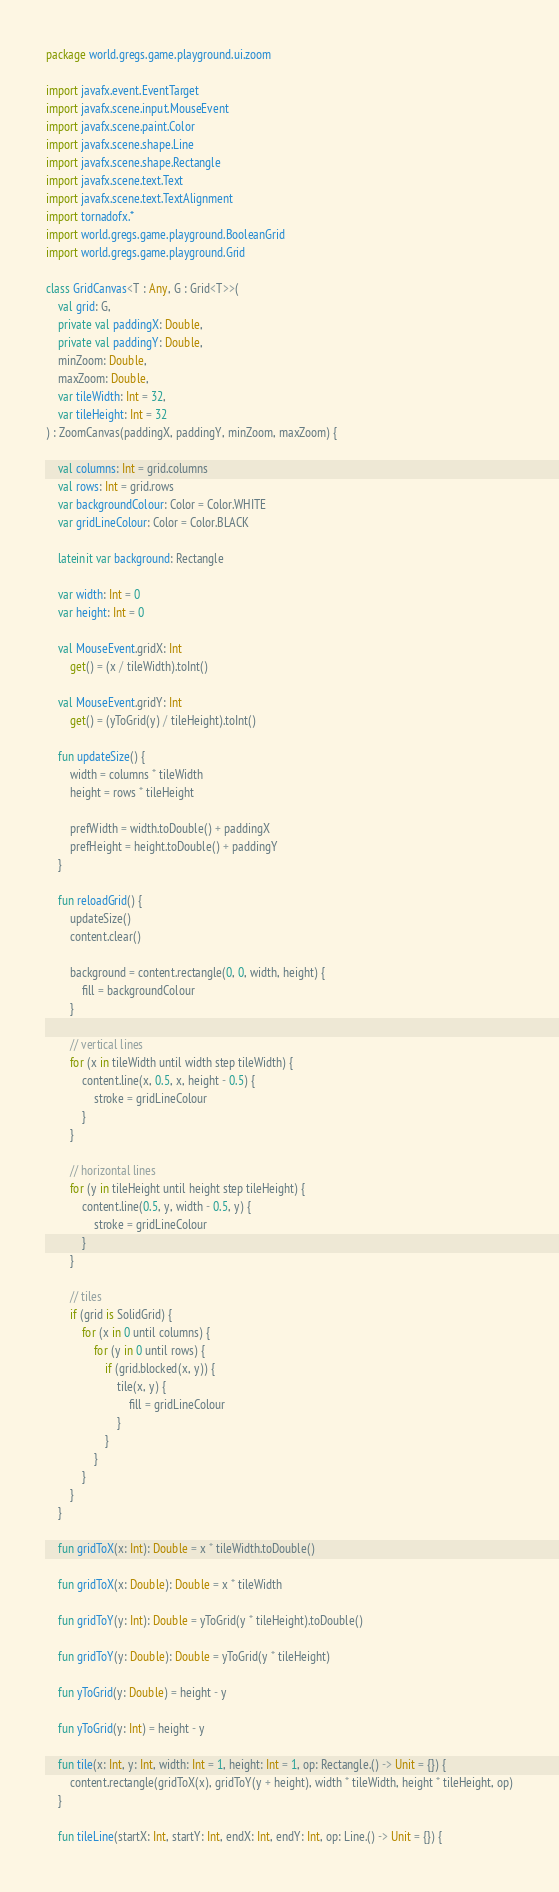<code> <loc_0><loc_0><loc_500><loc_500><_Kotlin_>package world.gregs.game.playground.ui.zoom

import javafx.event.EventTarget
import javafx.scene.input.MouseEvent
import javafx.scene.paint.Color
import javafx.scene.shape.Line
import javafx.scene.shape.Rectangle
import javafx.scene.text.Text
import javafx.scene.text.TextAlignment
import tornadofx.*
import world.gregs.game.playground.BooleanGrid
import world.gregs.game.playground.Grid

class GridCanvas<T : Any, G : Grid<T>>(
    val grid: G,
    private val paddingX: Double,
    private val paddingY: Double,
    minZoom: Double,
    maxZoom: Double,
    var tileWidth: Int = 32,
    var tileHeight: Int = 32
) : ZoomCanvas(paddingX, paddingY, minZoom, maxZoom) {

    val columns: Int = grid.columns
    val rows: Int = grid.rows
    var backgroundColour: Color = Color.WHITE
    var gridLineColour: Color = Color.BLACK

    lateinit var background: Rectangle

    var width: Int = 0
    var height: Int = 0

    val MouseEvent.gridX: Int
        get() = (x / tileWidth).toInt()

    val MouseEvent.gridY: Int
        get() = (yToGrid(y) / tileHeight).toInt()

    fun updateSize() {
        width = columns * tileWidth
        height = rows * tileHeight

        prefWidth = width.toDouble() + paddingX
        prefHeight = height.toDouble() + paddingY
    }

    fun reloadGrid() {
        updateSize()
        content.clear()

        background = content.rectangle(0, 0, width, height) {
            fill = backgroundColour
        }

        // vertical lines
        for (x in tileWidth until width step tileWidth) {
            content.line(x, 0.5, x, height - 0.5) {
                stroke = gridLineColour
            }
        }

        // horizontal lines
        for (y in tileHeight until height step tileHeight) {
            content.line(0.5, y, width - 0.5, y) {
                stroke = gridLineColour
            }
        }

        // tiles
        if (grid is SolidGrid) {
            for (x in 0 until columns) {
                for (y in 0 until rows) {
                    if (grid.blocked(x, y)) {
                        tile(x, y) {
                            fill = gridLineColour
                        }
                    }
                }
            }
        }
    }

    fun gridToX(x: Int): Double = x * tileWidth.toDouble()

    fun gridToX(x: Double): Double = x * tileWidth

    fun gridToY(y: Int): Double = yToGrid(y * tileHeight).toDouble()

    fun gridToY(y: Double): Double = yToGrid(y * tileHeight)

    fun yToGrid(y: Double) = height - y

    fun yToGrid(y: Int) = height - y

    fun tile(x: Int, y: Int, width: Int = 1, height: Int = 1, op: Rectangle.() -> Unit = {}) {
        content.rectangle(gridToX(x), gridToY(y + height), width * tileWidth, height * tileHeight, op)
    }

    fun tileLine(startX: Int, startY: Int, endX: Int, endY: Int, op: Line.() -> Unit = {}) {</code> 